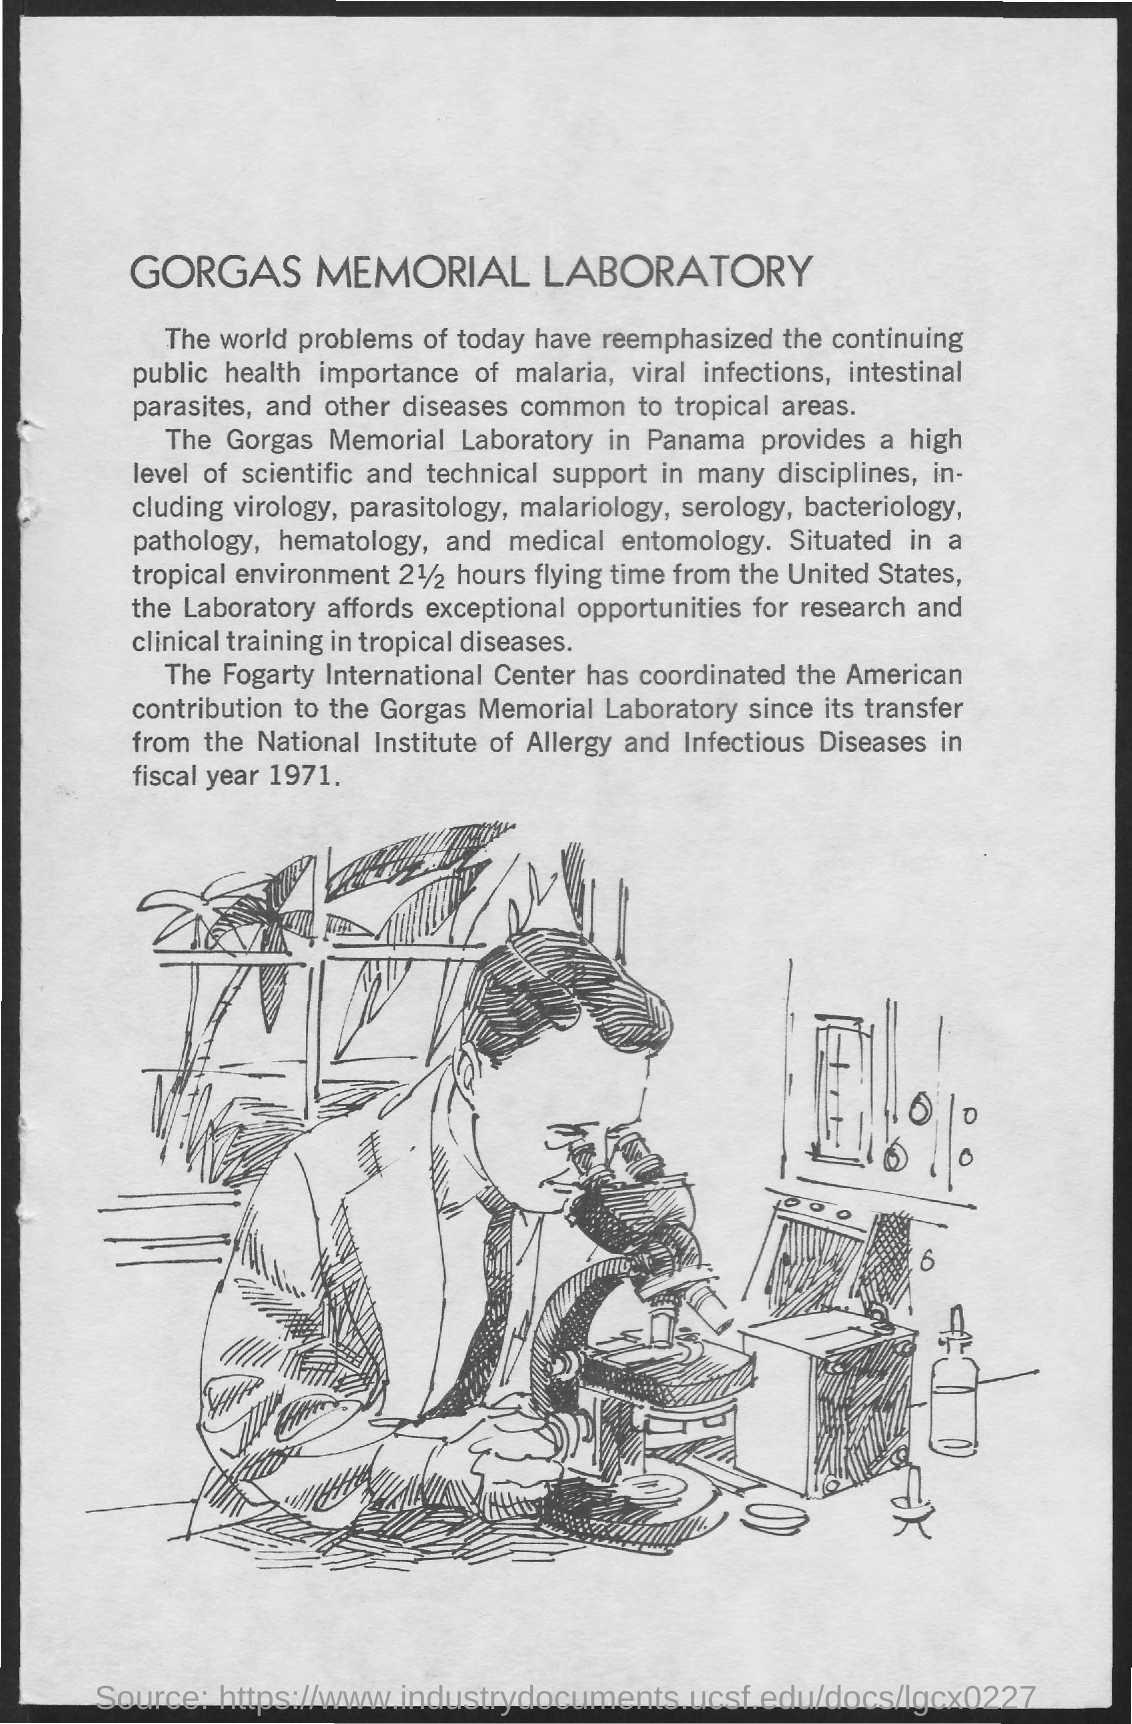Which laboratory is mentioned?
Offer a very short reply. The gorgas memorial laboratory. Where is the lab located?
Offer a terse response. Panama. What is the flying time from US to the Laboratory?
Give a very brief answer. 2 1/2 hours. In which fiscal year was the laboratory transferred?
Make the answer very short. 1971. 